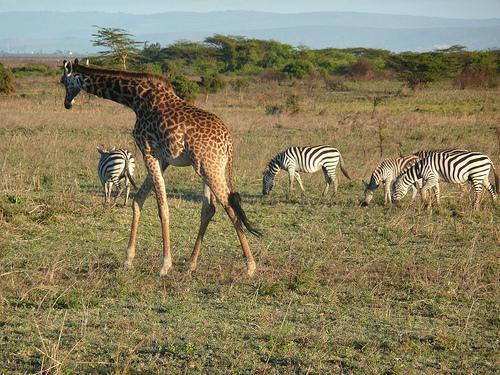How many giraffes in the image?
Give a very brief answer. 1. 